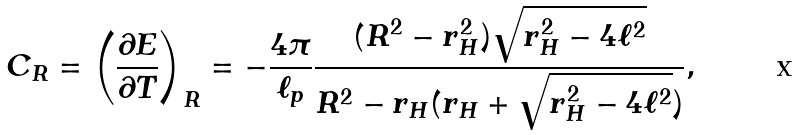Convert formula to latex. <formula><loc_0><loc_0><loc_500><loc_500>C _ { R } = \left ( \frac { \partial E } { \partial T } \right ) _ { R } = - \frac { 4 \pi } { \ell _ { p } } \frac { ( R ^ { 2 } - r _ { H } ^ { 2 } ) \sqrt { r _ { H } ^ { 2 } - 4 \ell ^ { 2 } } } { R ^ { 2 } - r _ { H } ( r _ { H } + \sqrt { r _ { H } ^ { 2 } - 4 \ell ^ { 2 } } ) } ,</formula> 